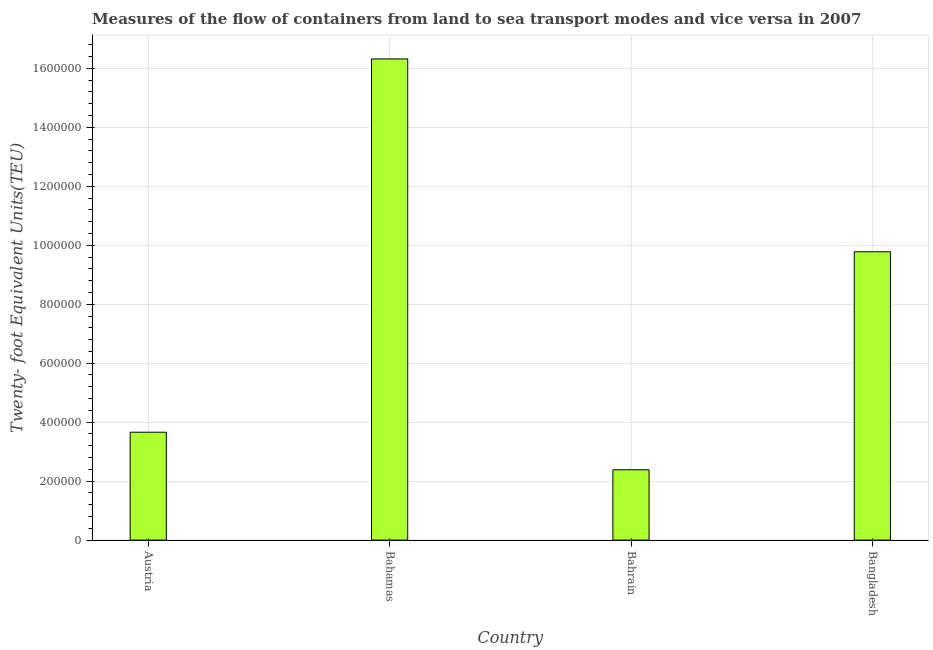Does the graph contain grids?
Your answer should be compact. Yes. What is the title of the graph?
Your response must be concise. Measures of the flow of containers from land to sea transport modes and vice versa in 2007. What is the label or title of the Y-axis?
Your answer should be very brief. Twenty- foot Equivalent Units(TEU). What is the container port traffic in Austria?
Offer a very short reply. 3.66e+05. Across all countries, what is the maximum container port traffic?
Keep it short and to the point. 1.63e+06. Across all countries, what is the minimum container port traffic?
Your answer should be compact. 2.39e+05. In which country was the container port traffic maximum?
Provide a succinct answer. Bahamas. In which country was the container port traffic minimum?
Make the answer very short. Bahrain. What is the sum of the container port traffic?
Offer a very short reply. 3.21e+06. What is the difference between the container port traffic in Bahamas and Bahrain?
Give a very brief answer. 1.39e+06. What is the average container port traffic per country?
Your answer should be compact. 8.04e+05. What is the median container port traffic?
Offer a terse response. 6.72e+05. In how many countries, is the container port traffic greater than 1040000 TEU?
Your answer should be very brief. 1. What is the ratio of the container port traffic in Bahamas to that in Bangladesh?
Keep it short and to the point. 1.67. Is the container port traffic in Bahamas less than that in Bahrain?
Offer a terse response. No. Is the difference between the container port traffic in Austria and Bahamas greater than the difference between any two countries?
Your answer should be very brief. No. What is the difference between the highest and the second highest container port traffic?
Provide a succinct answer. 6.54e+05. What is the difference between the highest and the lowest container port traffic?
Provide a short and direct response. 1.39e+06. How many bars are there?
Offer a very short reply. 4. What is the Twenty- foot Equivalent Units(TEU) of Austria?
Offer a terse response. 3.66e+05. What is the Twenty- foot Equivalent Units(TEU) in Bahamas?
Provide a short and direct response. 1.63e+06. What is the Twenty- foot Equivalent Units(TEU) of Bahrain?
Offer a very short reply. 2.39e+05. What is the Twenty- foot Equivalent Units(TEU) in Bangladesh?
Your answer should be very brief. 9.78e+05. What is the difference between the Twenty- foot Equivalent Units(TEU) in Austria and Bahamas?
Your response must be concise. -1.27e+06. What is the difference between the Twenty- foot Equivalent Units(TEU) in Austria and Bahrain?
Your answer should be very brief. 1.27e+05. What is the difference between the Twenty- foot Equivalent Units(TEU) in Austria and Bangladesh?
Your response must be concise. -6.12e+05. What is the difference between the Twenty- foot Equivalent Units(TEU) in Bahamas and Bahrain?
Keep it short and to the point. 1.39e+06. What is the difference between the Twenty- foot Equivalent Units(TEU) in Bahamas and Bangladesh?
Keep it short and to the point. 6.54e+05. What is the difference between the Twenty- foot Equivalent Units(TEU) in Bahrain and Bangladesh?
Provide a short and direct response. -7.39e+05. What is the ratio of the Twenty- foot Equivalent Units(TEU) in Austria to that in Bahamas?
Your answer should be compact. 0.22. What is the ratio of the Twenty- foot Equivalent Units(TEU) in Austria to that in Bahrain?
Ensure brevity in your answer.  1.53. What is the ratio of the Twenty- foot Equivalent Units(TEU) in Austria to that in Bangladesh?
Give a very brief answer. 0.37. What is the ratio of the Twenty- foot Equivalent Units(TEU) in Bahamas to that in Bahrain?
Your response must be concise. 6.84. What is the ratio of the Twenty- foot Equivalent Units(TEU) in Bahamas to that in Bangladesh?
Offer a terse response. 1.67. What is the ratio of the Twenty- foot Equivalent Units(TEU) in Bahrain to that in Bangladesh?
Offer a terse response. 0.24. 